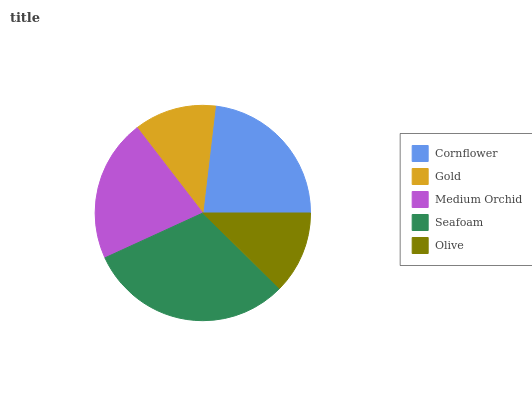Is Gold the minimum?
Answer yes or no. Yes. Is Seafoam the maximum?
Answer yes or no. Yes. Is Medium Orchid the minimum?
Answer yes or no. No. Is Medium Orchid the maximum?
Answer yes or no. No. Is Medium Orchid greater than Gold?
Answer yes or no. Yes. Is Gold less than Medium Orchid?
Answer yes or no. Yes. Is Gold greater than Medium Orchid?
Answer yes or no. No. Is Medium Orchid less than Gold?
Answer yes or no. No. Is Medium Orchid the high median?
Answer yes or no. Yes. Is Medium Orchid the low median?
Answer yes or no. Yes. Is Gold the high median?
Answer yes or no. No. Is Seafoam the low median?
Answer yes or no. No. 